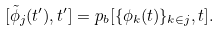<formula> <loc_0><loc_0><loc_500><loc_500>[ \tilde { \phi } _ { j } ( t ^ { \prime } ) , t ^ { \prime } ] = p _ { b } [ \{ \phi _ { k } ( t ) \} _ { k \in j } , t ] .</formula> 